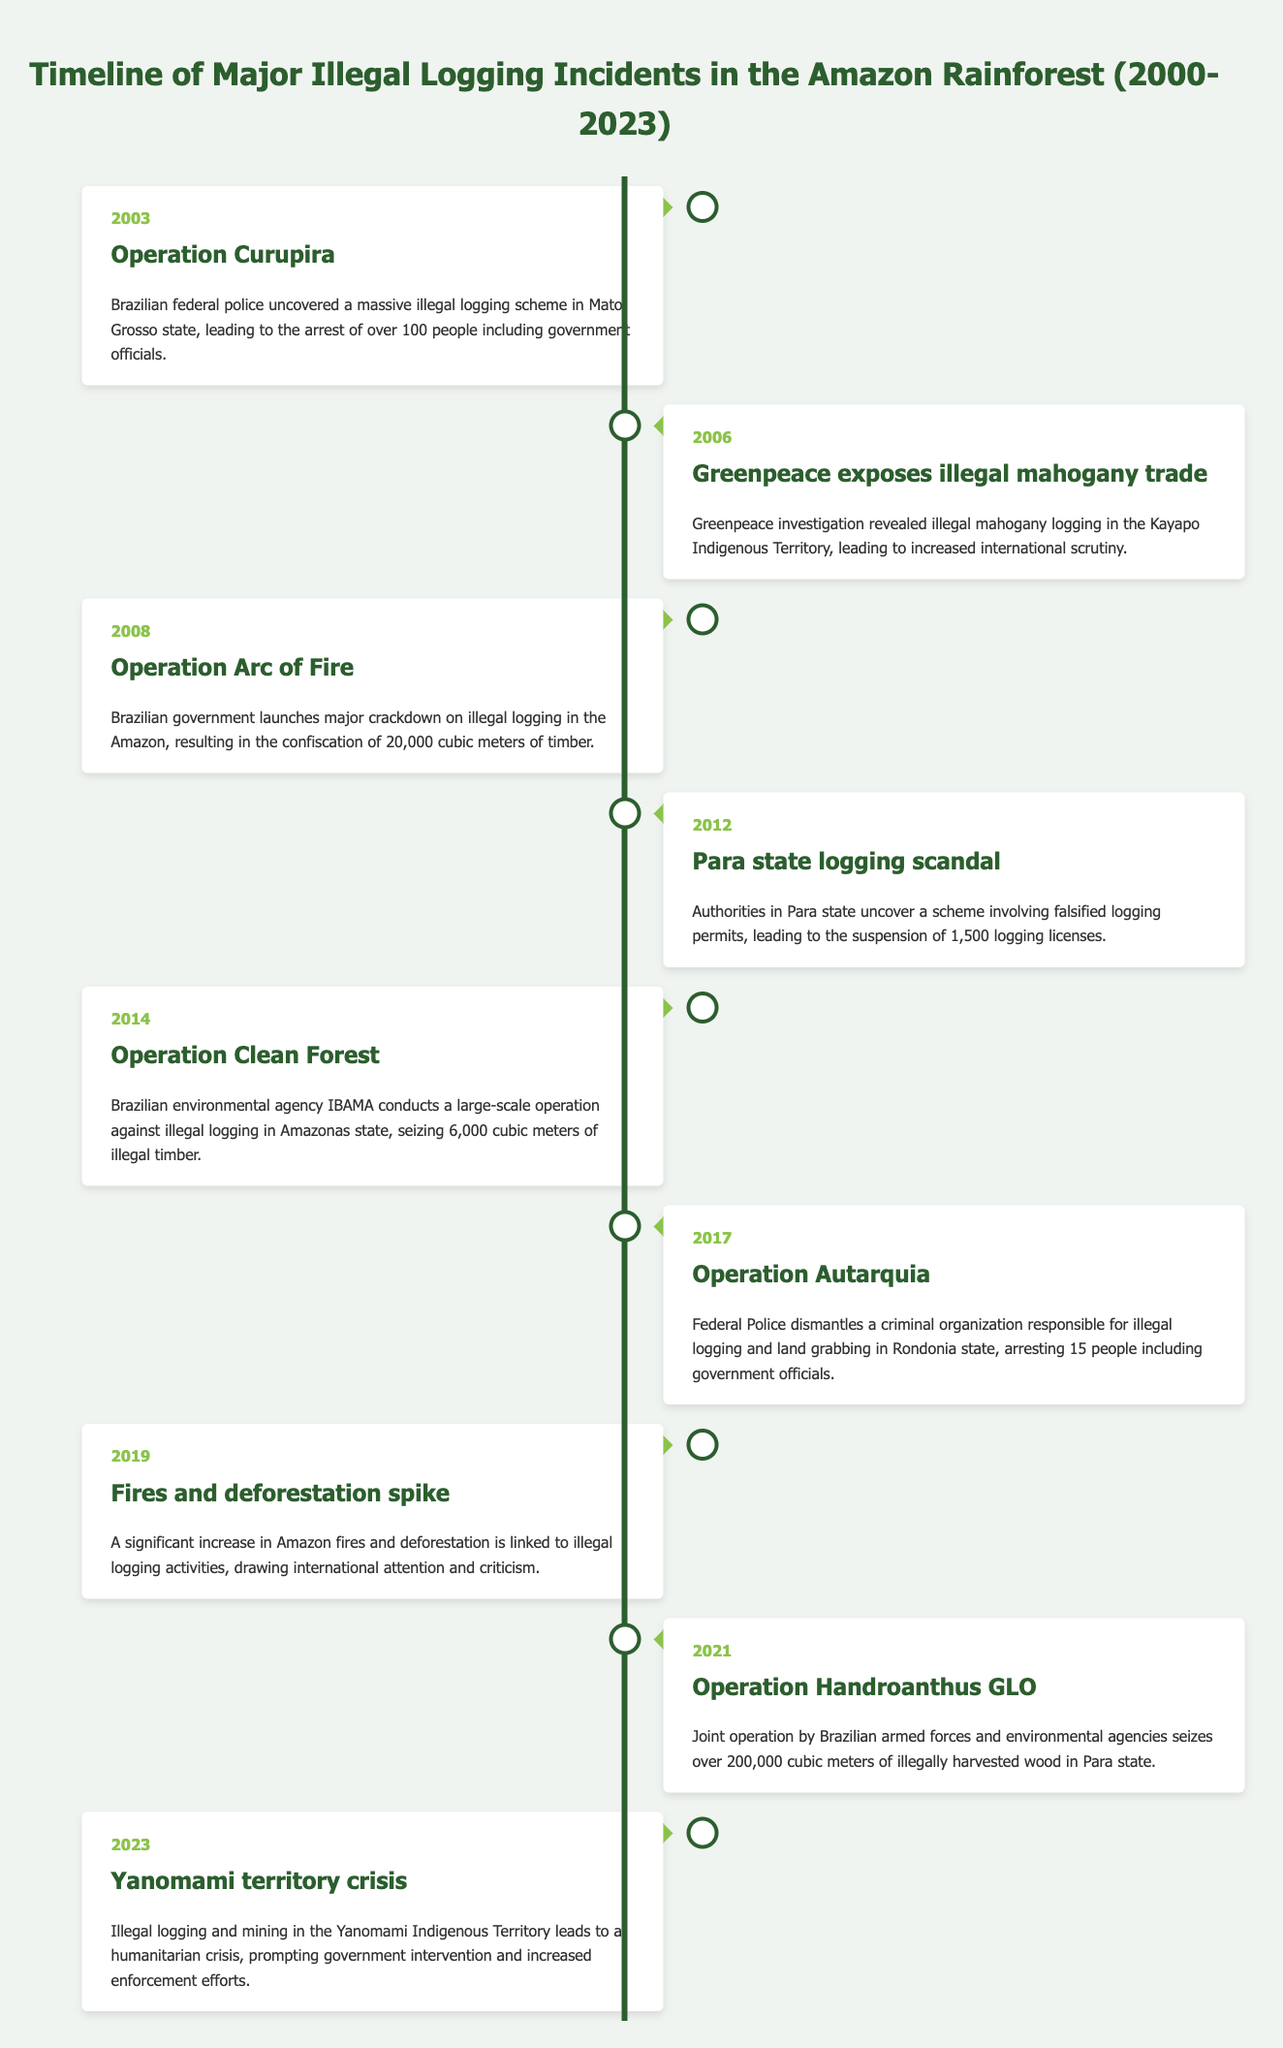What significant operation occurred in 2003 concerning illegal logging? The table lists "Operation Curupira" as the significant event in 2003. It mentions that Brazilian federal police uncovered a massive illegal logging scheme in Mato Grosso state, leading to the arrest of over 100 people including government officials.
Answer: Operation Curupira Which two years experienced significant operations against illegal logging conducted by Brazilian authorities? The table highlights major operations in 2008 with "Operation Arc of Fire" and in 2014 with "Operation Clean Forest." Both operations were led by Brazilian authorities against illegal logging, with specific outcomes detailed in their descriptions.
Answer: 2008 and 2014 True or False: The event in 2019 was linked to a spike in illegal logging activities. The table indicates that in 2019, there was a significant increase in Amazon fires and deforestation that was linked to illegal logging activities. Thus, this statement is true.
Answer: True What is the total amount of illegal timber seized during Operations Clean Forest and Handroanthus GLO? According to the table, Operation Clean Forest in 2014 seized 6,000 cubic meters of illegal timber, and Operation Handroanthus GLO in 2021 seized over 200,000 cubic meters. Summing these values gives 6,000 + 200,000 = 206,000 cubic meters of timber seized.
Answer: 206,000 cubic meters In which year did the crisis in Yanomami territory lead to increased enforcement efforts? The table indicates that the Yanomami territory crisis occurred in 2023, with illegal logging and mining interventions leading to government action and heightened enforcement efforts.
Answer: 2023 Which incident prompted international scrutiny regarding illegal logging in Indigenous territories? The table notes that in 2006, Greenpeace's exposure of illegal mahogany trade in the Kayapo Indigenous Territory led to increased international scrutiny, making it a notable incident.
Answer: Greenpeace exposes illegal mahogany trade in 2006 How many logging licenses were suspended during the Para state logging scandal? The table provides information about the Para state logging scandal in 2012, stating that 1,500 logging licenses were suspended due to a scheme involving falsified logging permits.
Answer: 1,500 logging licenses What is the difference in years between the Operation Autarquia and Operation Clean Forest? Operation Autarquia took place in 2017, while Operation Clean Forest occurred in 2014. The difference in years is 2017 - 2014 = 3 years.
Answer: 3 years 